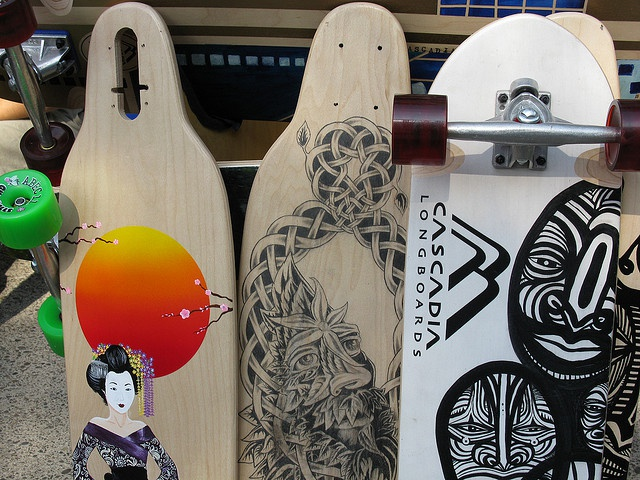Describe the objects in this image and their specific colors. I can see skateboard in lightblue, black, lightgray, and darkgray tones, skateboard in lightblue, darkgray, brown, tan, and black tones, skateboard in lightblue, darkgray, gray, and black tones, and skateboard in lightblue, black, and gray tones in this image. 